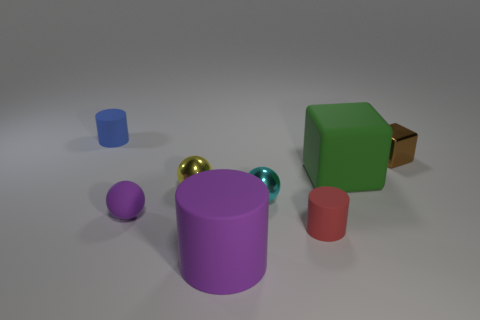Subtract all gray blocks. Subtract all blue spheres. How many blocks are left? 2 Add 2 purple metal balls. How many objects exist? 10 Subtract all cubes. How many objects are left? 6 Add 5 red rubber objects. How many red rubber objects are left? 6 Add 5 tiny cyan rubber balls. How many tiny cyan rubber balls exist? 5 Subtract 1 brown cubes. How many objects are left? 7 Subtract all tiny purple matte objects. Subtract all shiny blocks. How many objects are left? 6 